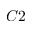<formula> <loc_0><loc_0><loc_500><loc_500>C 2</formula> 